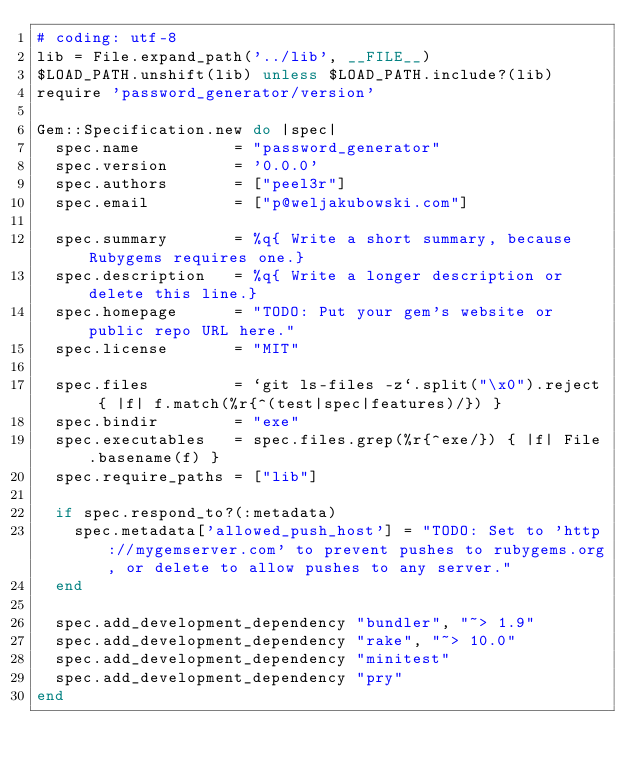<code> <loc_0><loc_0><loc_500><loc_500><_Ruby_># coding: utf-8
lib = File.expand_path('../lib', __FILE__)
$LOAD_PATH.unshift(lib) unless $LOAD_PATH.include?(lib)
require 'password_generator/version'

Gem::Specification.new do |spec|
  spec.name          = "password_generator"
  spec.version       = '0.0.0'
  spec.authors       = ["peel3r"]
  spec.email         = ["p@weljakubowski.com"]

  spec.summary       = %q{ Write a short summary, because Rubygems requires one.}
  spec.description   = %q{ Write a longer description or delete this line.}
  spec.homepage      = "TODO: Put your gem's website or public repo URL here."
  spec.license       = "MIT"

  spec.files         = `git ls-files -z`.split("\x0").reject { |f| f.match(%r{^(test|spec|features)/}) }
  spec.bindir        = "exe"
  spec.executables   = spec.files.grep(%r{^exe/}) { |f| File.basename(f) }
  spec.require_paths = ["lib"]

  if spec.respond_to?(:metadata)
    spec.metadata['allowed_push_host'] = "TODO: Set to 'http://mygemserver.com' to prevent pushes to rubygems.org, or delete to allow pushes to any server."
  end

  spec.add_development_dependency "bundler", "~> 1.9"
  spec.add_development_dependency "rake", "~> 10.0"
  spec.add_development_dependency "minitest"
  spec.add_development_dependency "pry"
end
</code> 